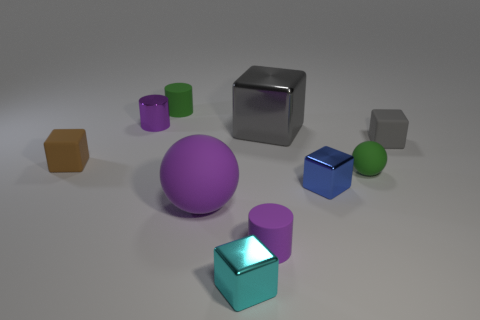Subtract all big shiny cubes. How many cubes are left? 4 Subtract all green cylinders. How many cylinders are left? 2 Subtract all spheres. How many objects are left? 8 Add 2 cyan metallic things. How many cyan metallic things are left? 3 Add 7 big cubes. How many big cubes exist? 8 Subtract 0 purple blocks. How many objects are left? 10 Subtract 3 cylinders. How many cylinders are left? 0 Subtract all cyan spheres. Subtract all yellow cubes. How many spheres are left? 2 Subtract all purple spheres. How many purple blocks are left? 0 Subtract all large gray matte blocks. Subtract all small purple things. How many objects are left? 8 